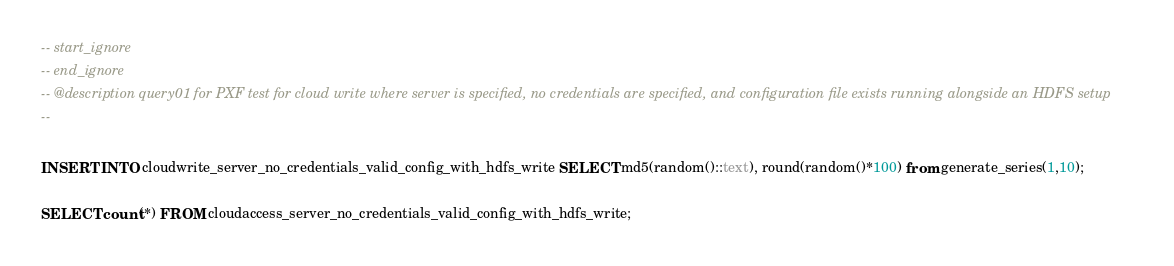Convert code to text. <code><loc_0><loc_0><loc_500><loc_500><_SQL_>-- start_ignore
-- end_ignore
-- @description query01 for PXF test for cloud write where server is specified, no credentials are specified, and configuration file exists running alongside an HDFS setup
--

INSERT INTO cloudwrite_server_no_credentials_valid_config_with_hdfs_write SELECT md5(random()::text), round(random()*100) from generate_series(1,10);

SELECT count(*) FROM cloudaccess_server_no_credentials_valid_config_with_hdfs_write;
</code> 